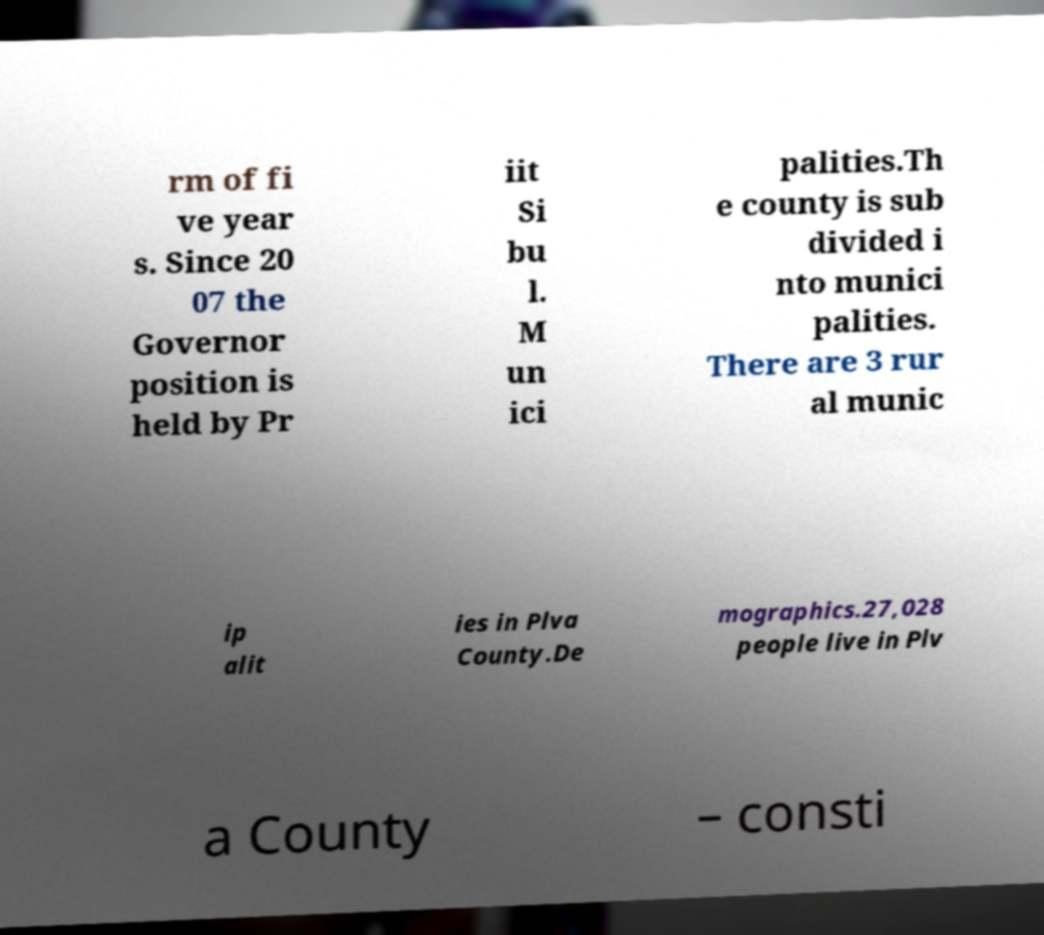Can you accurately transcribe the text from the provided image for me? rm of fi ve year s. Since 20 07 the Governor position is held by Pr iit Si bu l. M un ici palities.Th e county is sub divided i nto munici palities. There are 3 rur al munic ip alit ies in Plva County.De mographics.27,028 people live in Plv a County – consti 